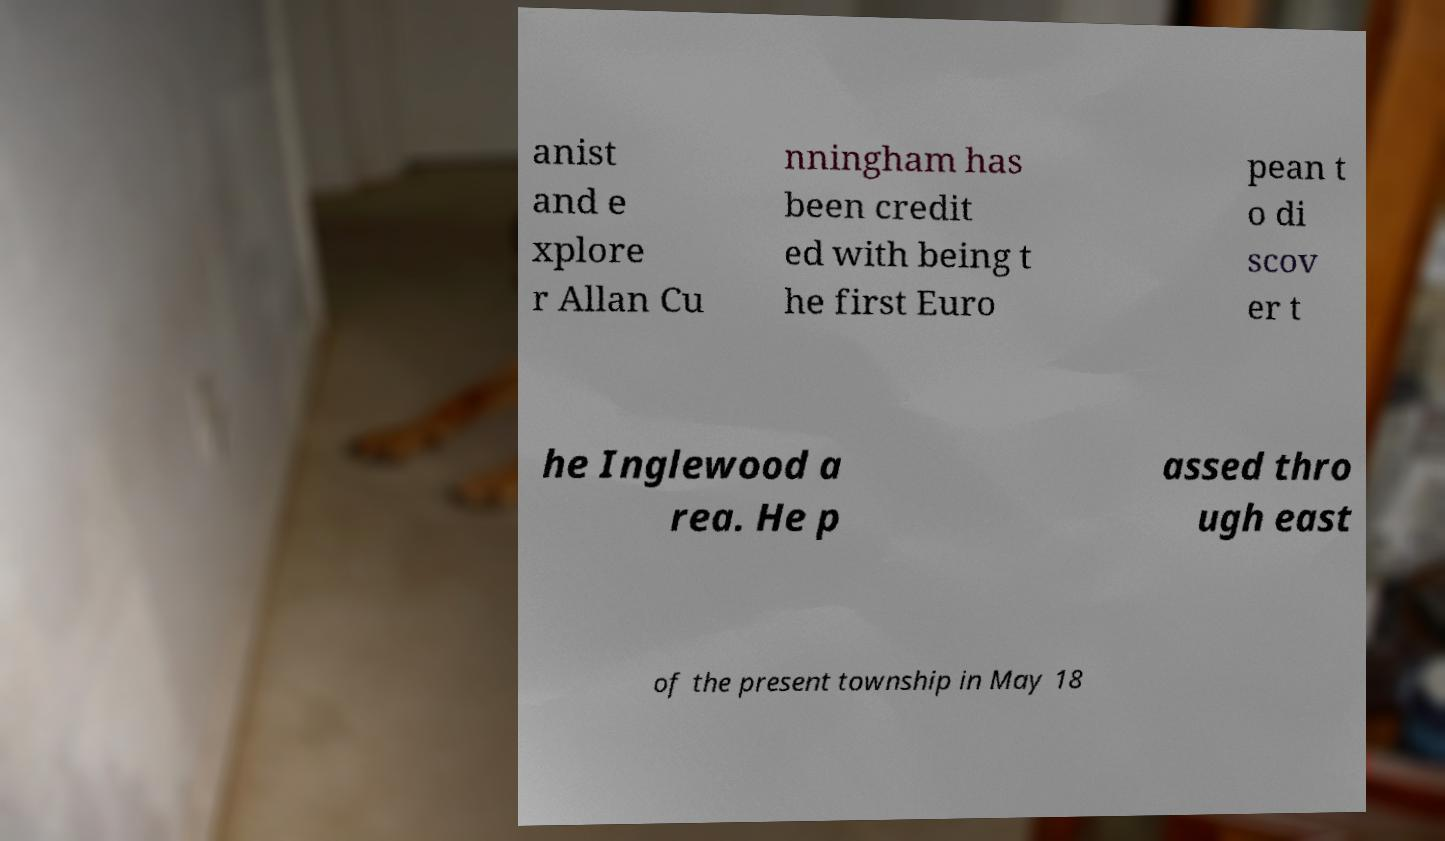Could you extract and type out the text from this image? anist and e xplore r Allan Cu nningham has been credit ed with being t he first Euro pean t o di scov er t he Inglewood a rea. He p assed thro ugh east of the present township in May 18 